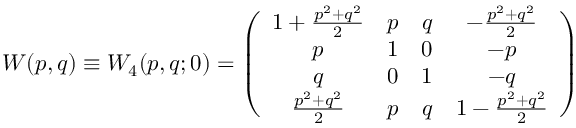<formula> <loc_0><loc_0><loc_500><loc_500>W ( p , q ) \equiv W _ { 4 } ( p , q ; 0 ) = \left ( \begin{array} { c c c c } { { 1 + \frac { p ^ { 2 } + q ^ { 2 } } { 2 } } } & { p } & { q } & { { - \frac { p ^ { 2 } + q ^ { 2 } } { 2 } } } \\ { p } & { 1 } & { 0 } & { - p } \\ { q } & { 0 } & { 1 } & { - q } \\ { { \frac { p ^ { 2 } + q ^ { 2 } } { 2 } } } & { p } & { q } & { { 1 - \frac { p ^ { 2 } + q ^ { 2 } } { 2 } } } \end{array} \right )</formula> 